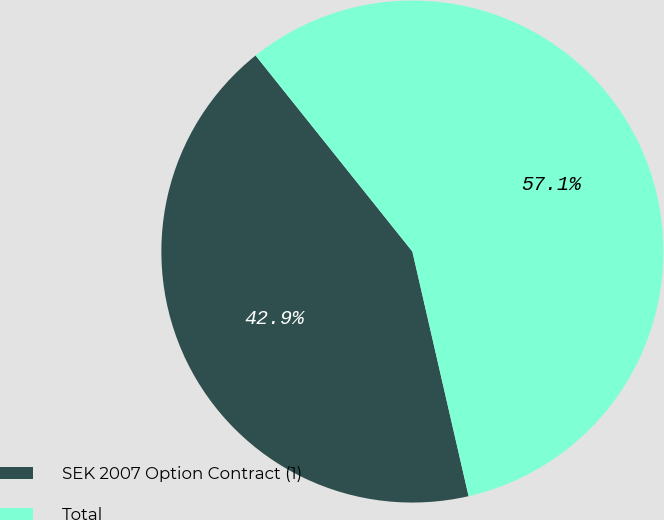Convert chart to OTSL. <chart><loc_0><loc_0><loc_500><loc_500><pie_chart><fcel>SEK 2007 Option Contract (1)<fcel>Total<nl><fcel>42.86%<fcel>57.14%<nl></chart> 